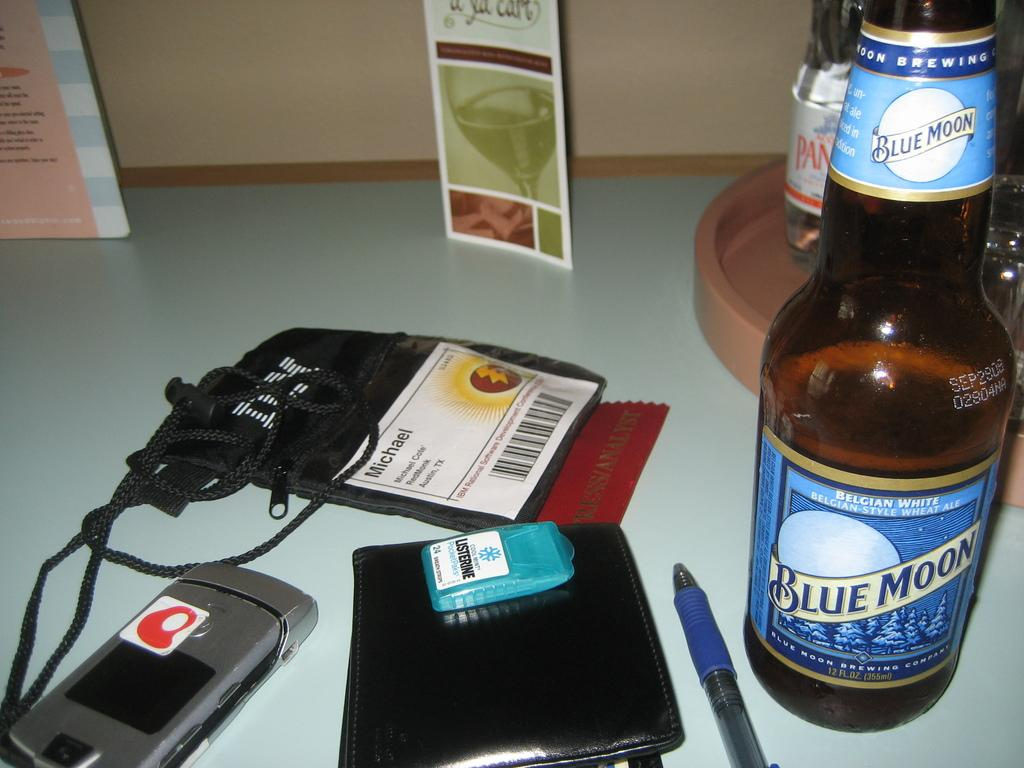<image>
Render a clear and concise summary of the photo. Bottle of Blue Moon beer next to a pack of Listerine strips. 